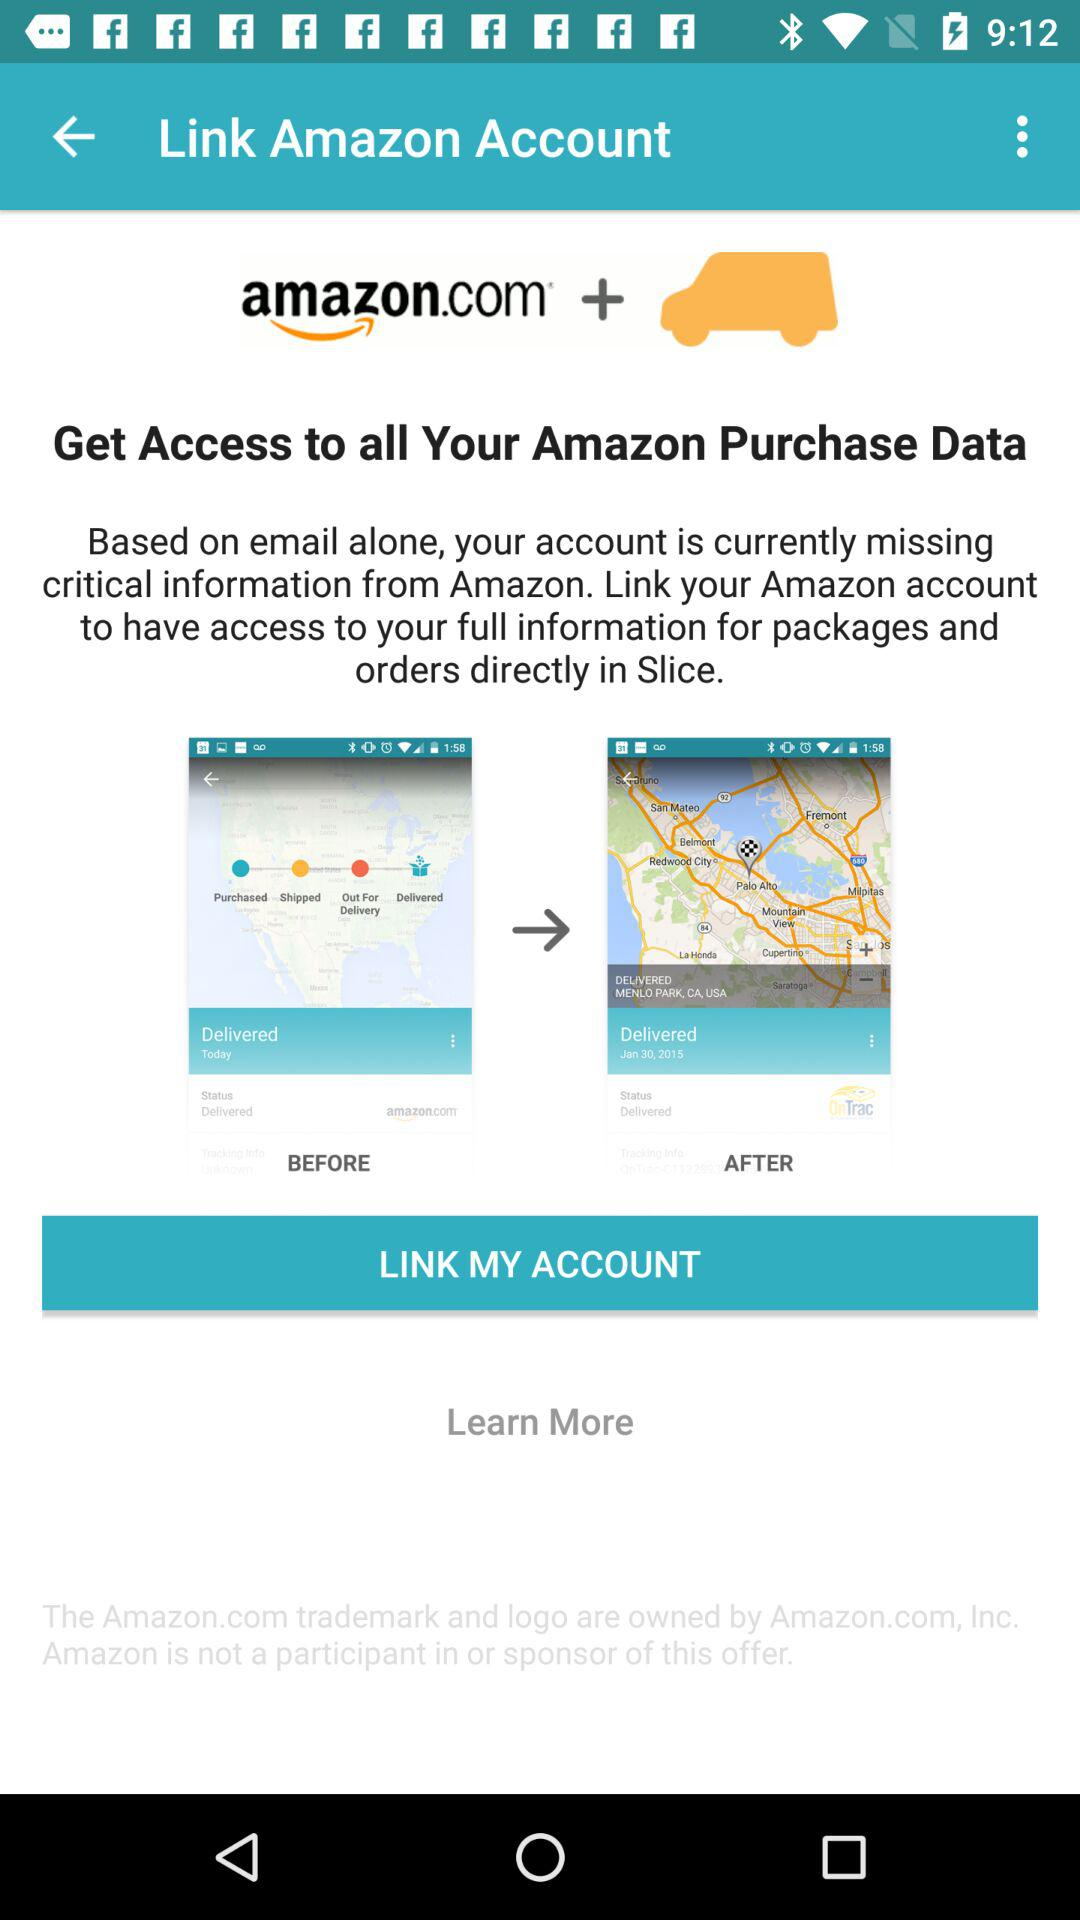What is the name of application? The name of the application is "amazon.com". 